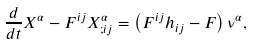Convert formula to latex. <formula><loc_0><loc_0><loc_500><loc_500>\frac { d } { d t } X ^ { \alpha } - F ^ { i j } X ^ { \alpha } _ { ; i j } = \left ( F ^ { i j } h _ { i j } - F \right ) \nu ^ { \alpha } ,</formula> 